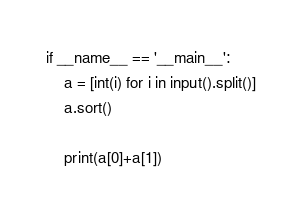Convert code to text. <code><loc_0><loc_0><loc_500><loc_500><_Python_>if __name__ == '__main__':
    a = [int(i) for i in input().split()]
    a.sort()

    print(a[0]+a[1])
</code> 